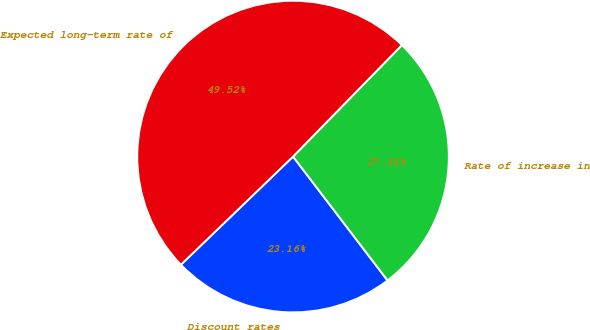Convert chart to OTSL. <chart><loc_0><loc_0><loc_500><loc_500><pie_chart><fcel>Discount rates<fcel>Rate of increase in<fcel>Expected long-term rate of<nl><fcel>23.16%<fcel>27.32%<fcel>49.52%<nl></chart> 